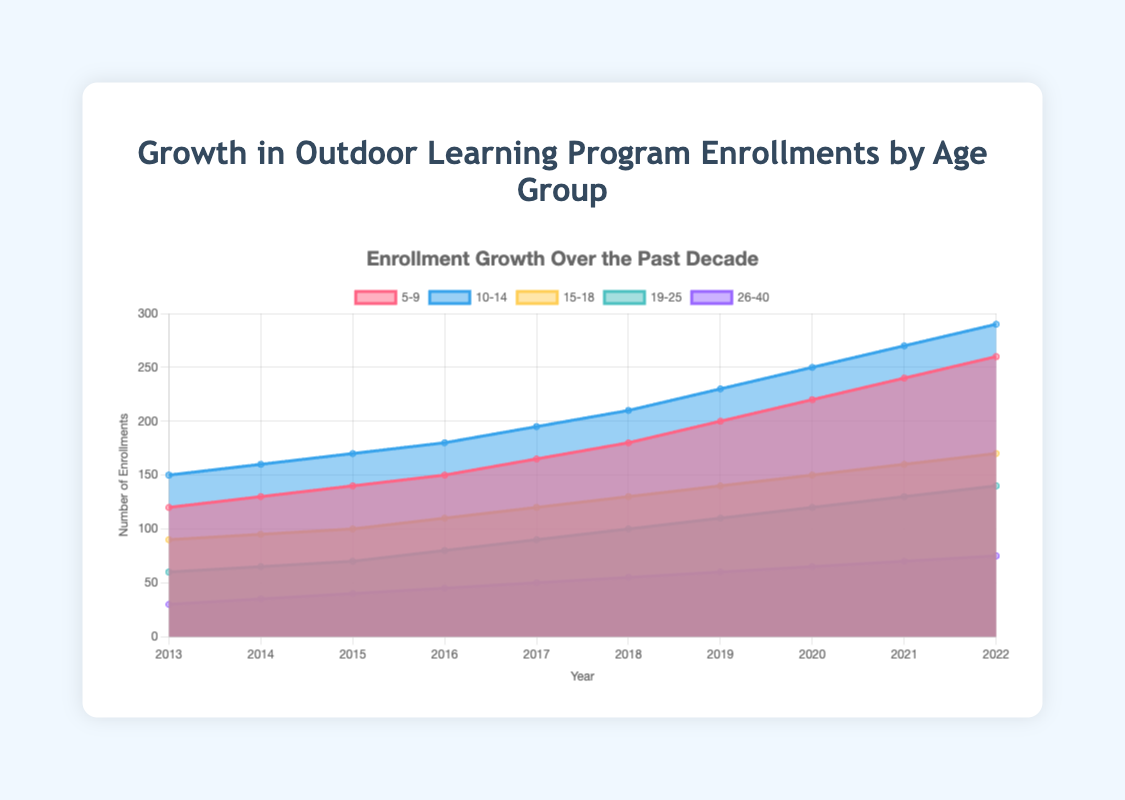What's the title of the chart? The title is located at the top, written in a large font, making it quite visible. It reads "Growth in Outdoor Learning Program Enrollments by Age Group."
Answer: Growth in Outdoor Learning Program Enrollments by Age Group How many age groups are displayed in the figure? There are five different colored areas or stacked lines in the chart, each representing a distinct age group.
Answer: Five Which age group had the highest number of enrollments in 2022? The highest enrollment for each year can be identified by looking at the topmost area for that year. In 2022, the topmost area represents the 10-14 age group.
Answer: 10-14 What was the trend for the 19-25 age group from 2013 to 2022? Tracking the 19-25 group from left to right, the enrollments increased every year.
Answer: Consistently increasing Which year saw the biggest increase in enrollments for the 5-9 age group? By examining the height differences year over year, the largest increase occurs from 2019 to 2020. The 5-9 enrollment grows from 200 to 220.
Answer: 2019 to 2020 Compare the enrollments for the 15-18 age group in 2015 and 2018. For 2015, the enrollment is 100, and for 2018, it's 130. So the enrollment increased by 30.
Answer: Increased by 30 How do total enrollments for all age groups in 2022 compare to those in 2013? Add up the enrollments for each age group for both years (2013 and 2022). Summing 120+150+90+60+30=450 for 2013, and 260+290+170+140+75=935 for 2022. So, 2022 had 485 more enrollments.
Answer: 485 more enrollments in 2022 Which age group's enrollment showed the least growth over the decade? By comparing the starting and ending values, the 26-40 age group saw the smallest increment, from 30 to 75, which is an increase of 45.
Answer: 26-40 What was the average number of enrollments for the 10-14 age group from 2013 to 2016? To find the average, add the enrollments from 2013 (150), 2014 (160), 2015 (170), and 2016 (180) and then divide by 4. (150+160+170+180)/4 = 165.
Answer: 165 